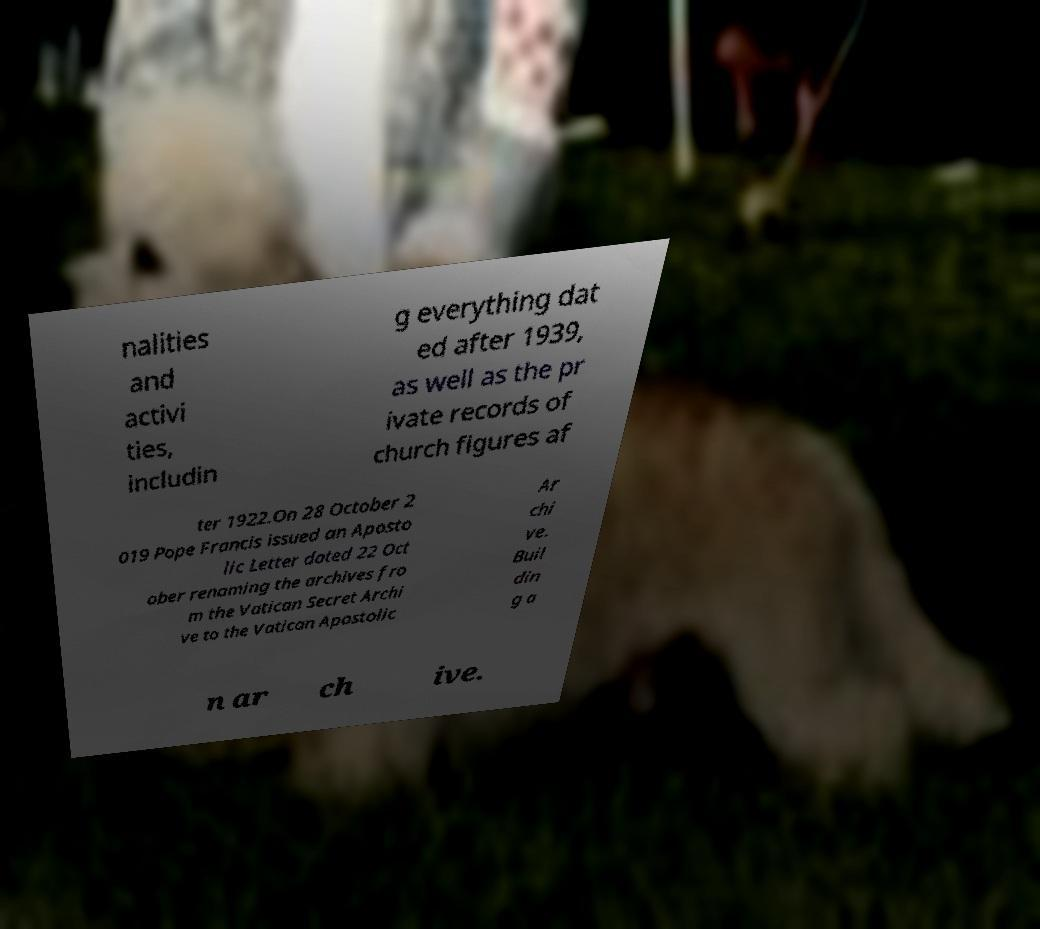Can you read and provide the text displayed in the image?This photo seems to have some interesting text. Can you extract and type it out for me? nalities and activi ties, includin g everything dat ed after 1939, as well as the pr ivate records of church figures af ter 1922.On 28 October 2 019 Pope Francis issued an Aposto lic Letter dated 22 Oct ober renaming the archives fro m the Vatican Secret Archi ve to the Vatican Apostolic Ar chi ve. Buil din g a n ar ch ive. 